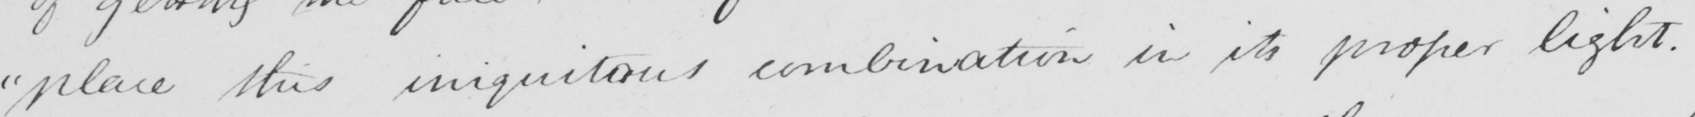Can you tell me what this handwritten text says? " place this iniquitous combination in its proper light . 